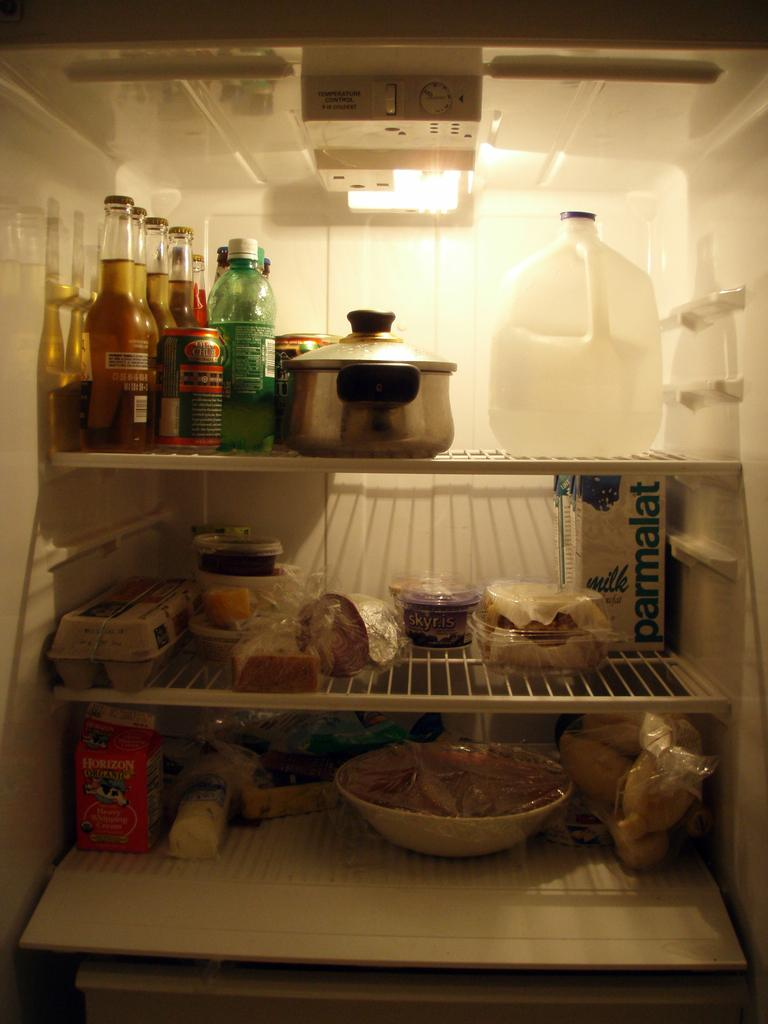<image>
Render a clear and concise summary of the photo. A refridgerator that includes Horizon milk and milk called parmalat. 